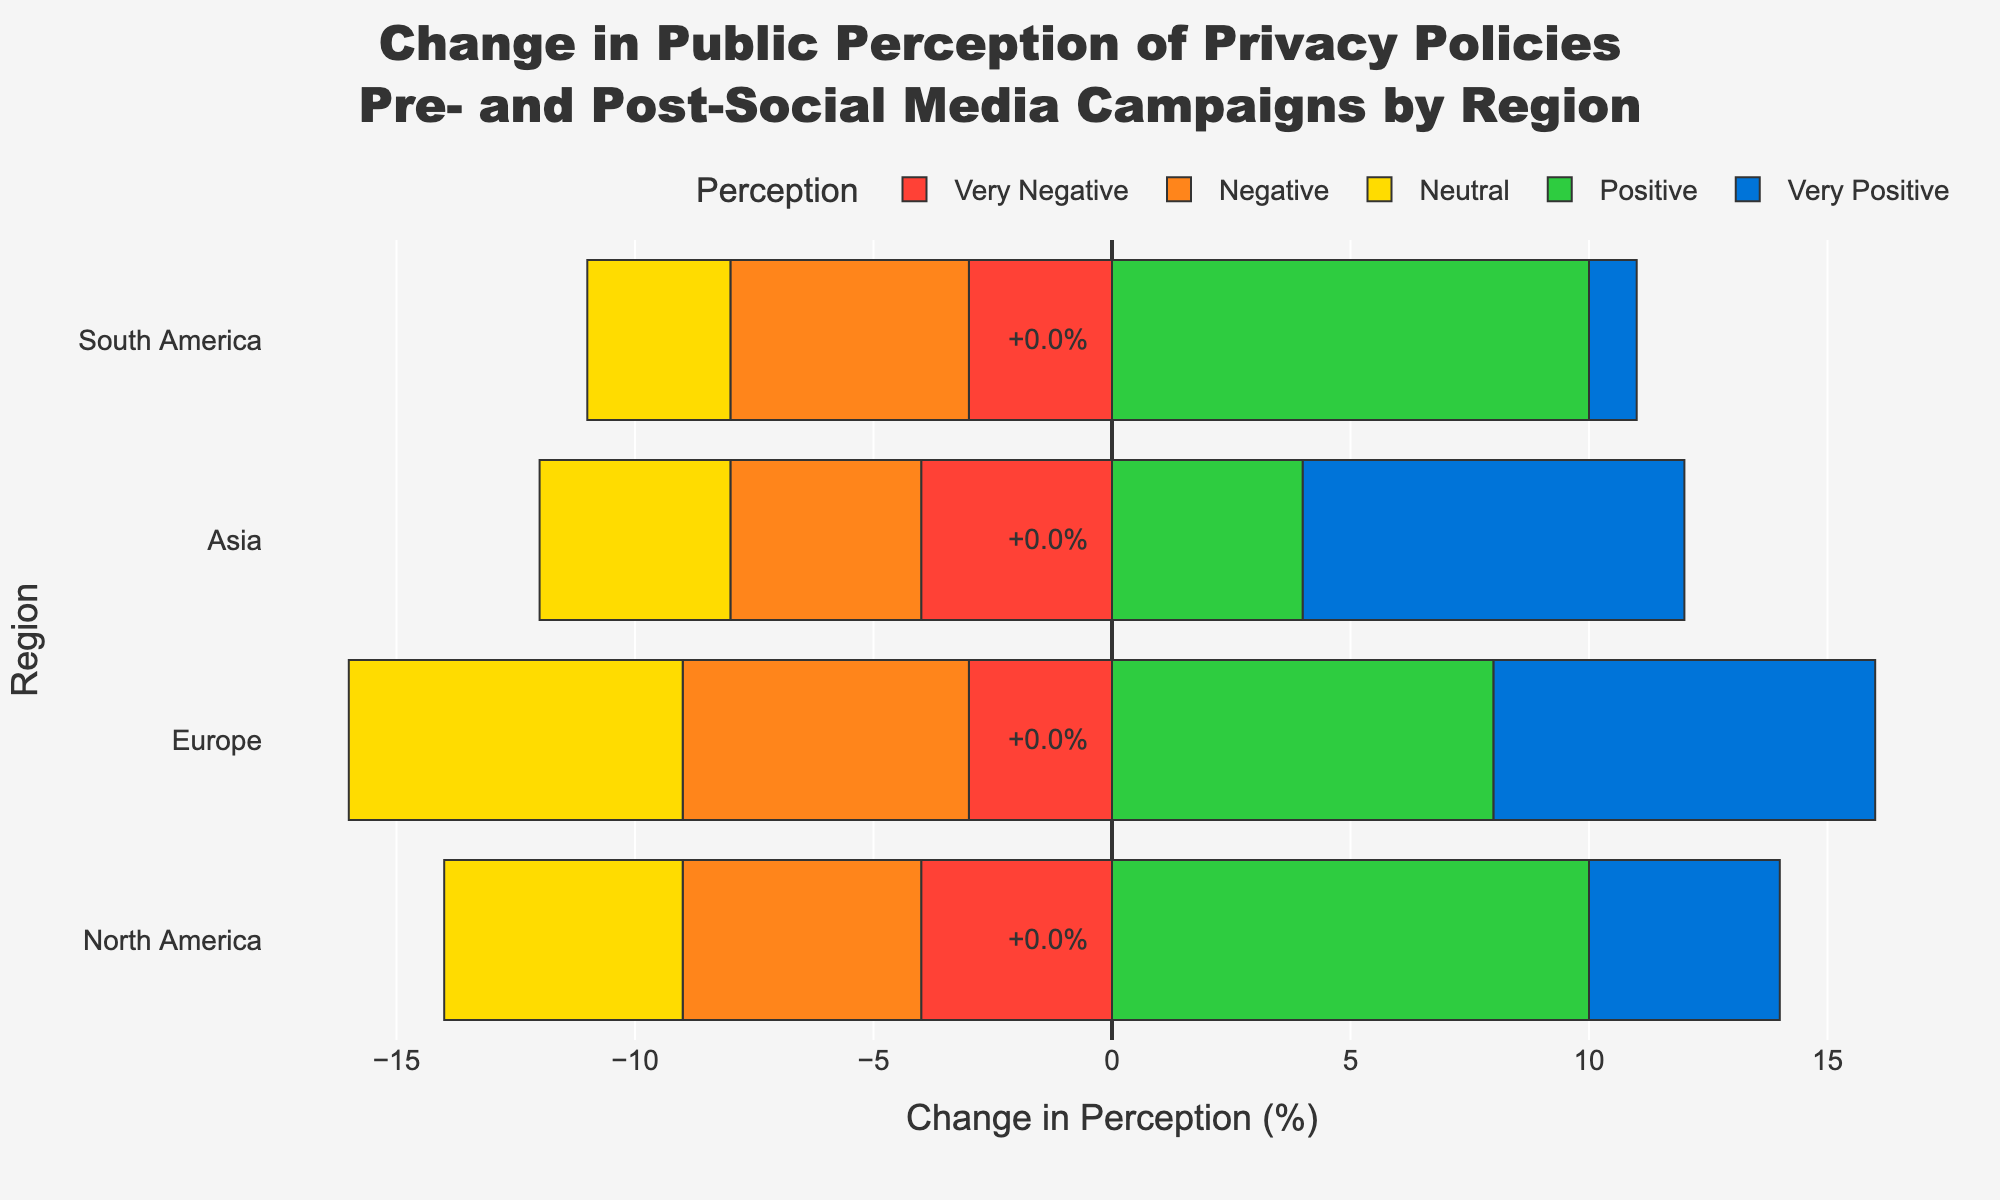What region experienced the highest increase in positive perception of privacy policies after the social media campaigns? Compare the "Positive" bar lengths for each region. North America shows an increase from 25 to 35 (10%), Europe from 30 to 38 (8%), Asia from 26 to 30 (4%), and South America from 20 to 30 (10%). Both North America and South America have the highest increase of 10%.
Answer: North America and South America Which perception category shows the greatest improvement in Europe after the campaign? Look at the bar lengths for Europe. "Very Positive" perception increased the most, from 9 to 17 (8%).
Answer: Very Positive What is the total net change in perception for North America? Sum the values of the 'Difference' for North America. (+4) - 10 for 'Very Negative', -5 for 'Negative', -5 for 'Neutral', +10 for 'Positive', and +4 for 'Very Positive'. Total net change = (-4) + (-5) + (-5) + (+10) + (+4) = 0
Answer: 0 Which region has the smallest overall change in perception after the social media campaign? Compare the total net change in perception for each region. North America (0), Europe (+3), Asia (+6), South America (+3). North America has the smallest change.
Answer: North America Did negative perceptions decrease more in Asia or South America? Compare the decrease in "Negative" perceptions. Asia decreased from 22 to 18 (4% decrease), South America decreased from 25 to 20 (5% decrease). South America shows a greater decrease in negative perception.
Answer: South America How did the neutral perception change in Europe after the campaign? Look at the "Neutral" bar length for Europe. It decreased from 35 to 28 (7% decrease).
Answer: 7% decrease In which region did the "Very Negative" perception decrease the most significantly? Compare the decrease in "Very Negative" perceptions. North America decreased from 10 to 6 (4% decrease), Europe from 8 to 5 (3% decrease), Asia from 12 to 8 (4% decrease), South America from 15 to 12 (3% decrease). Both North America and Asia had the most significant decrease of 4%.
Answer: North America and Asia Which perception category in Asia saw an increase after the social media campaign? Look at the bar lengths for Asia. "Positive" increased from 26 to 30 (4% increase), and "Very Positive" increased from 12 to 20 (8% increase). Both categories saw an increase.
Answer: Positive and Very Positive 